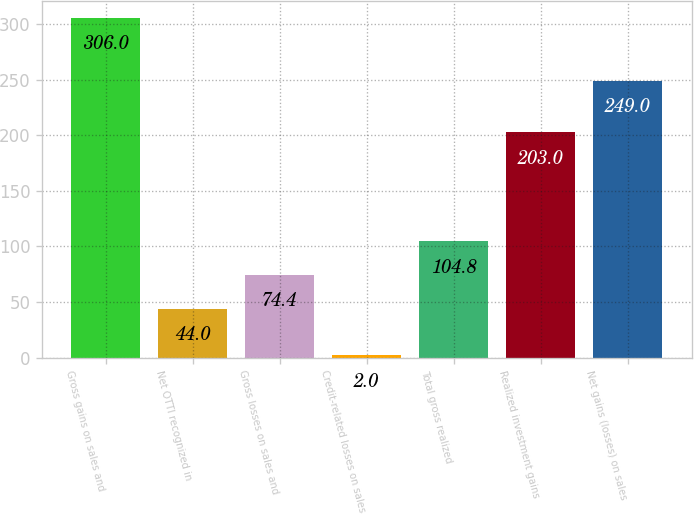<chart> <loc_0><loc_0><loc_500><loc_500><bar_chart><fcel>Gross gains on sales and<fcel>Net OTTI recognized in<fcel>Gross losses on sales and<fcel>Credit-related losses on sales<fcel>Total gross realized<fcel>Realized investment gains<fcel>Net gains (losses) on sales<nl><fcel>306<fcel>44<fcel>74.4<fcel>2<fcel>104.8<fcel>203<fcel>249<nl></chart> 